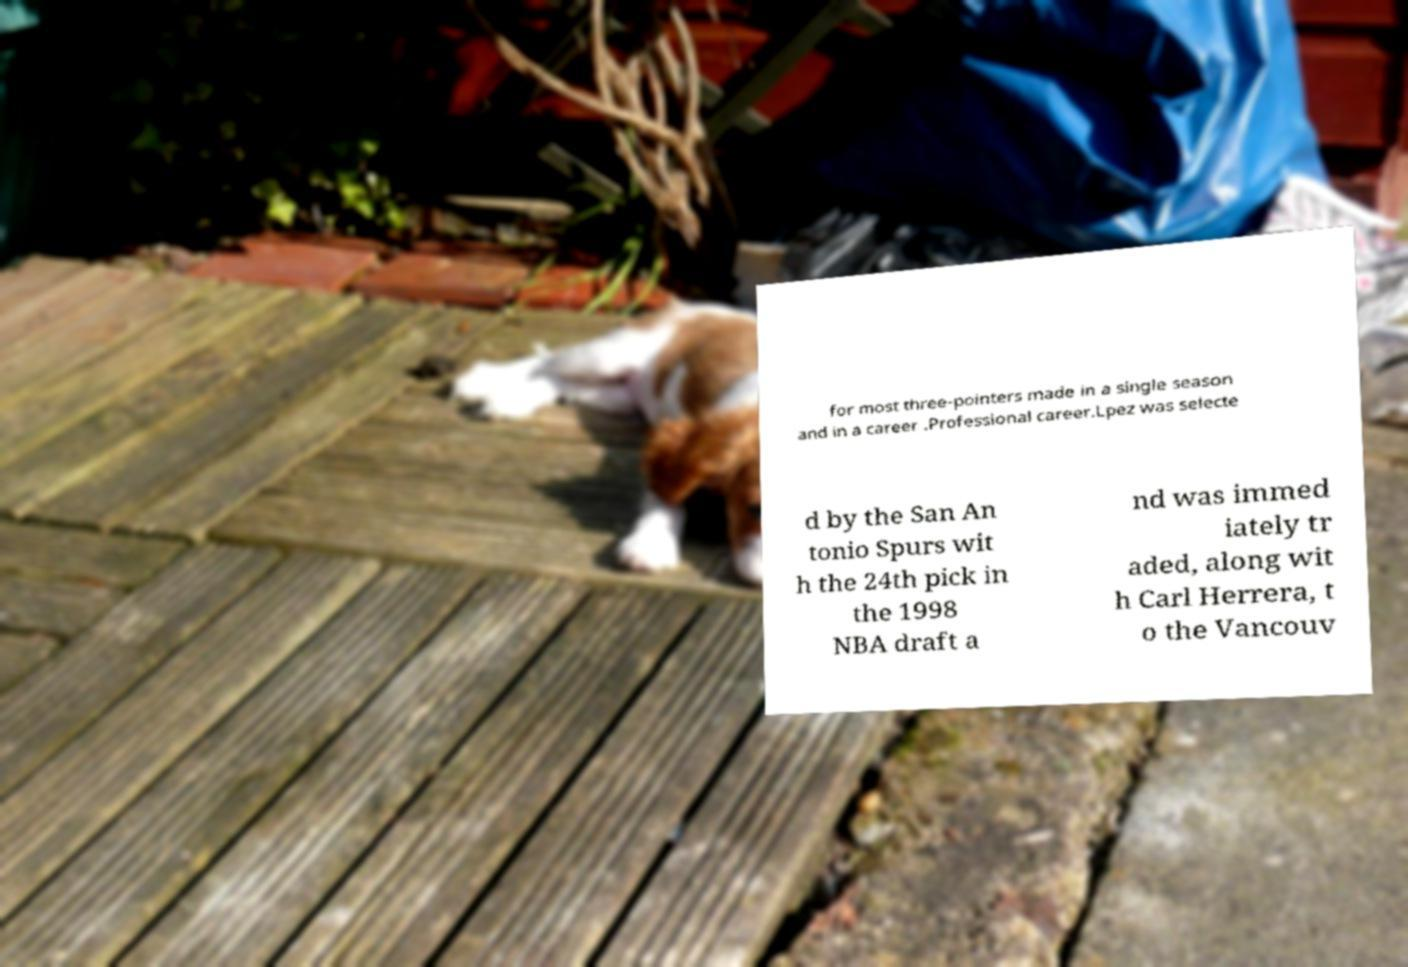Can you read and provide the text displayed in the image?This photo seems to have some interesting text. Can you extract and type it out for me? for most three-pointers made in a single season and in a career .Professional career.Lpez was selecte d by the San An tonio Spurs wit h the 24th pick in the 1998 NBA draft a nd was immed iately tr aded, along wit h Carl Herrera, t o the Vancouv 